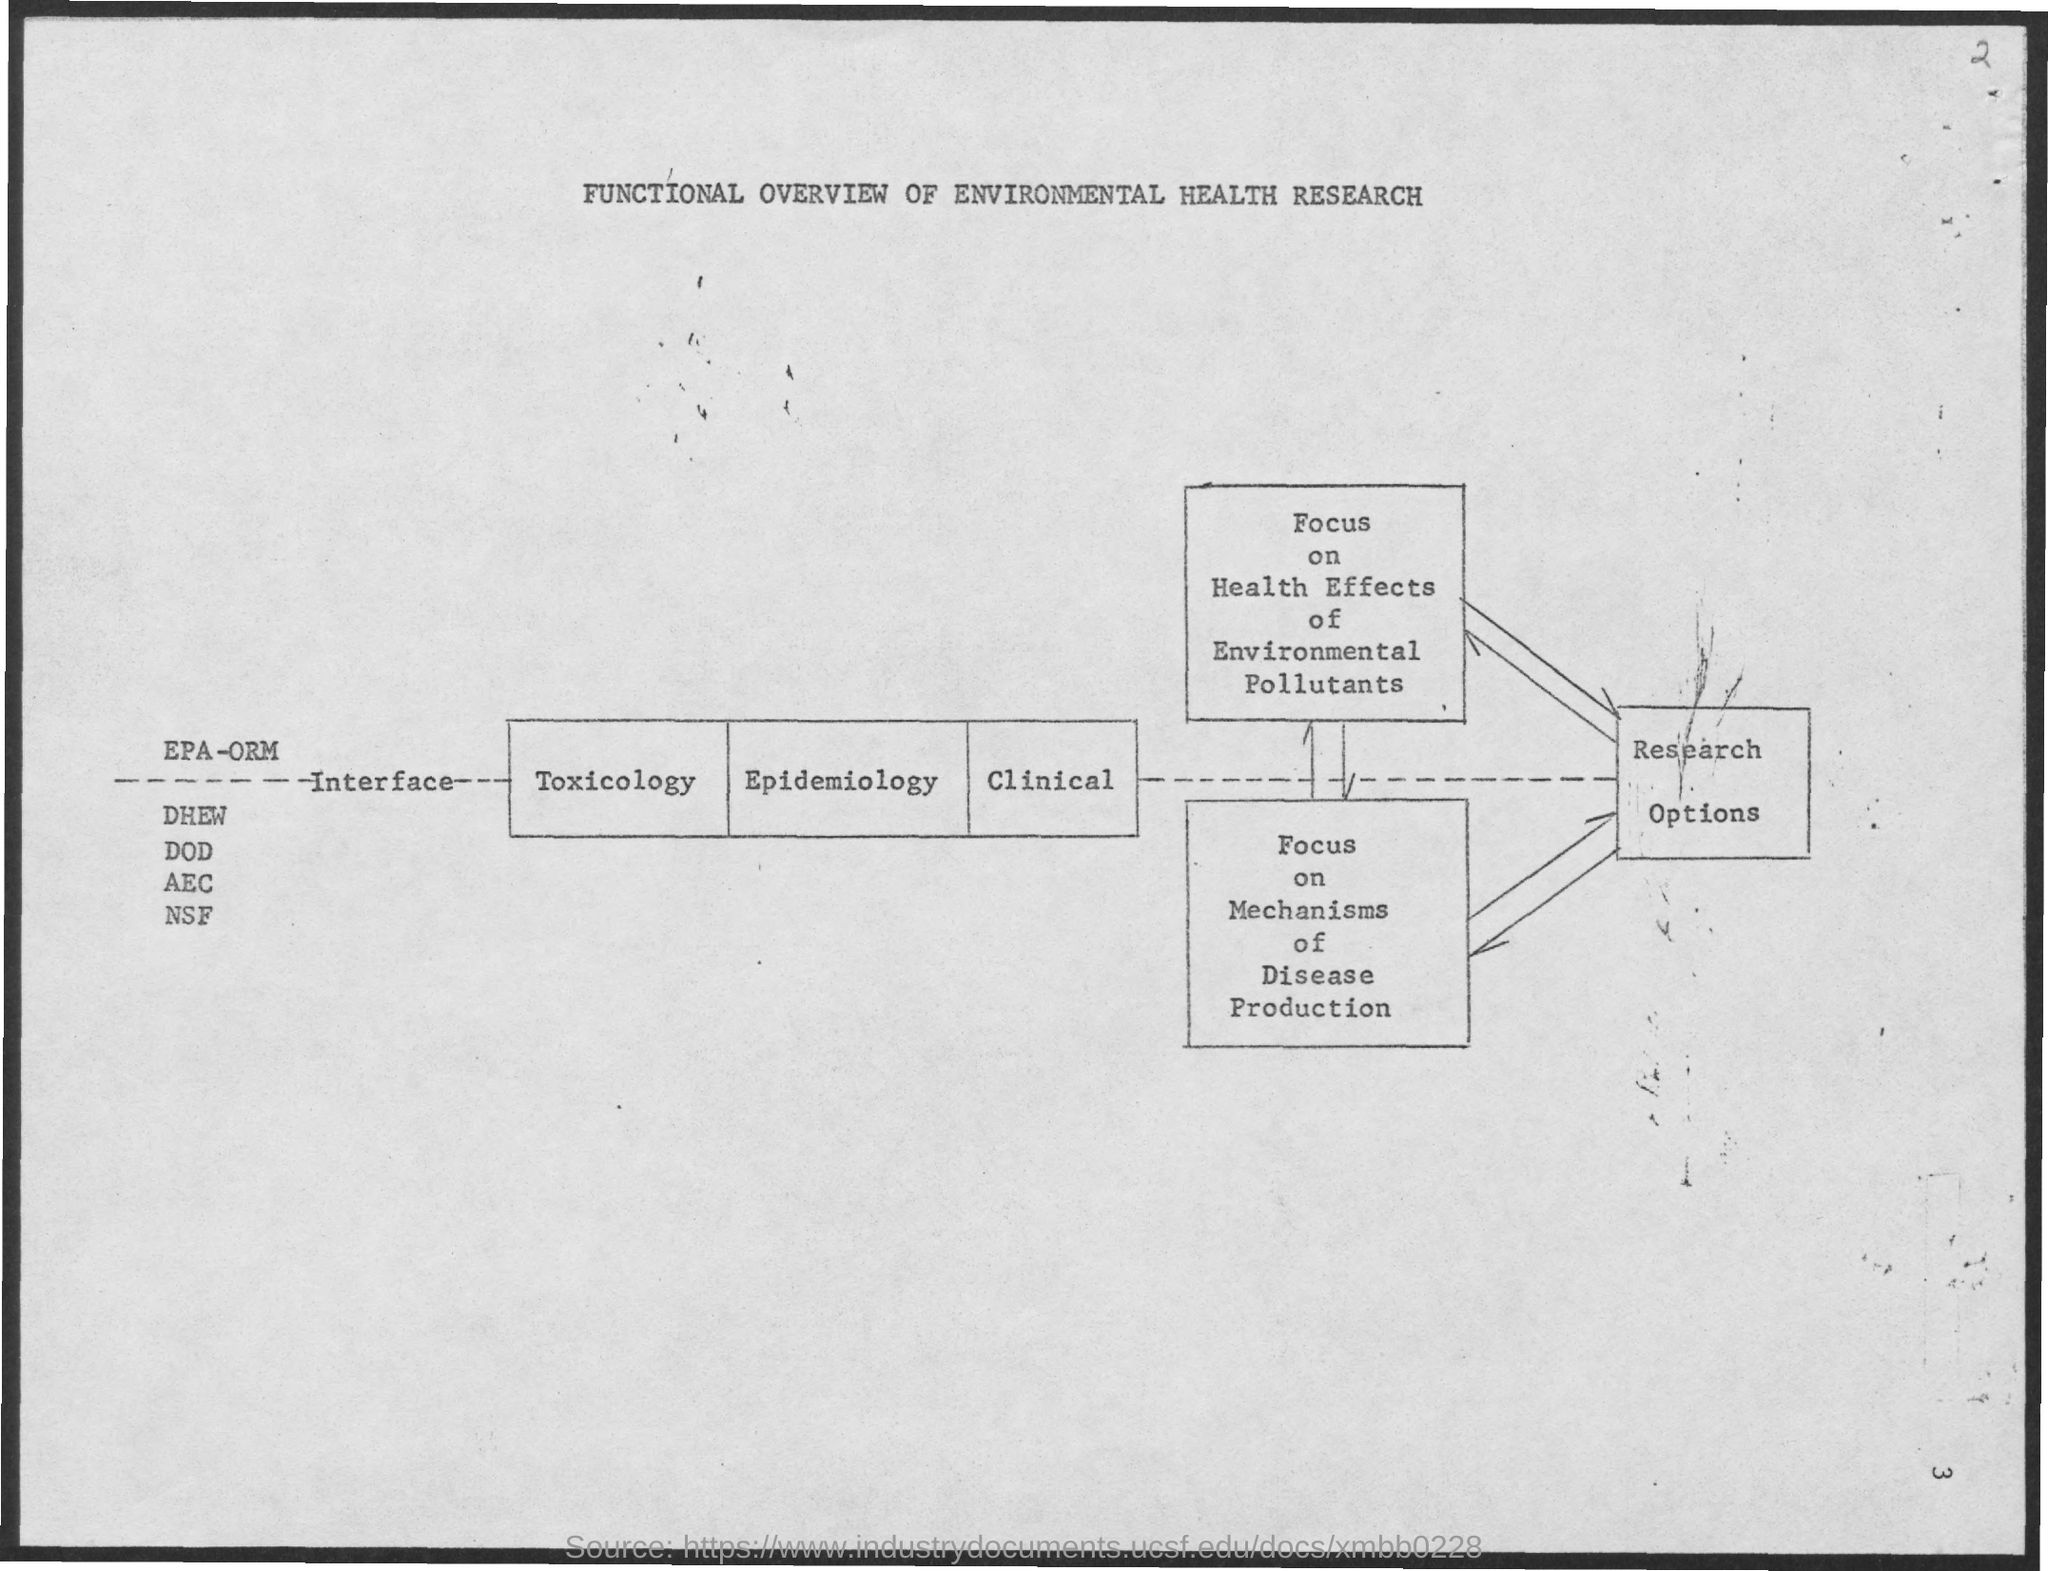What is the title of the document?
Offer a very short reply. Functional overview of environmental health research. 